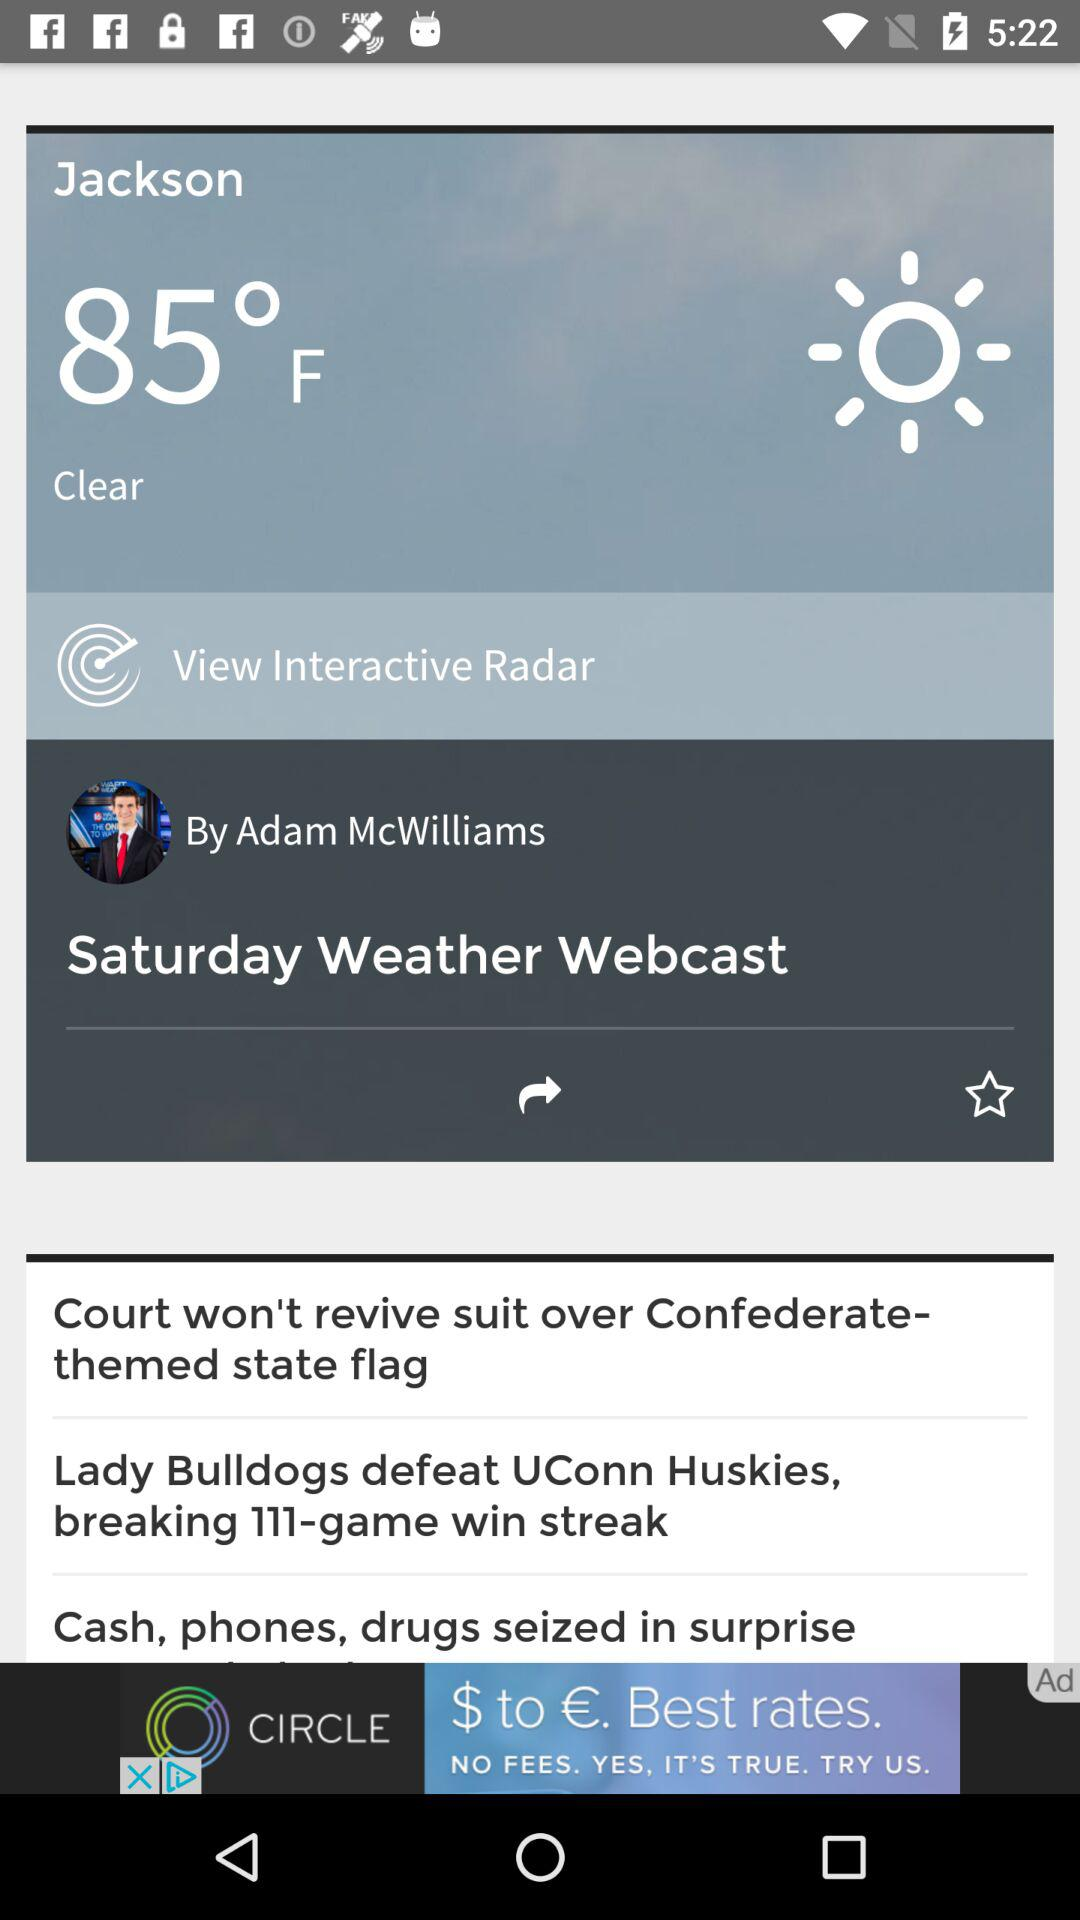How many degrees Fahrenheit is the temperature?
Answer the question using a single word or phrase. 85°F 